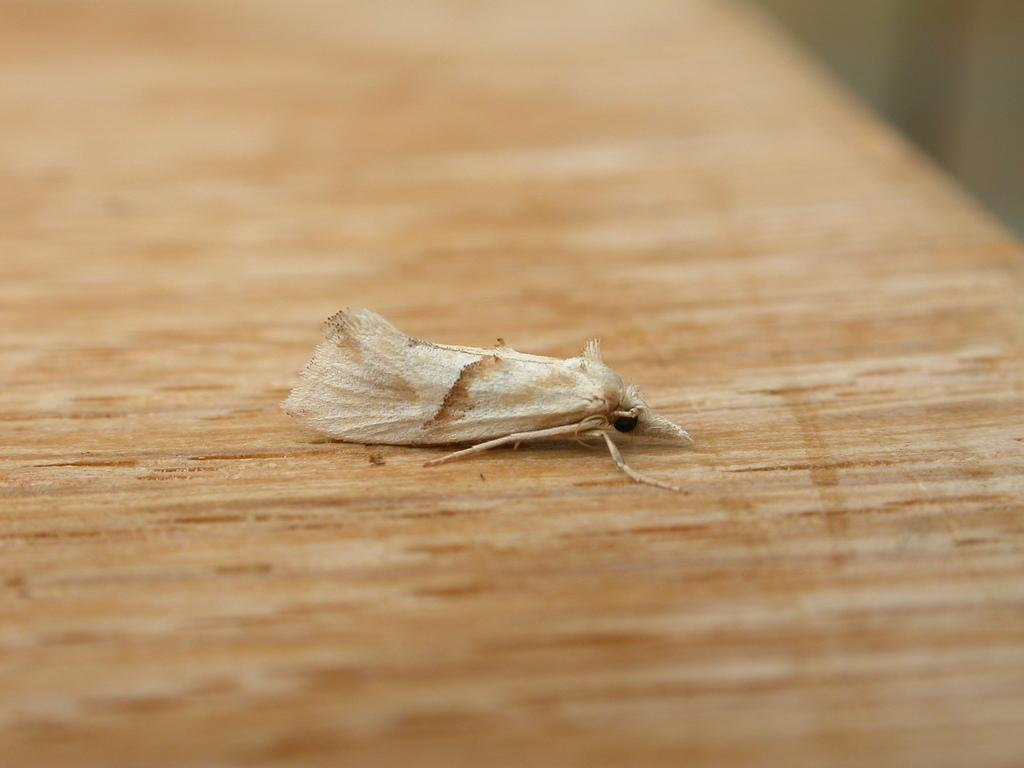What is the main subject in the center of the image? There is a fly in the center of the image. What type of surface is the fly on? The fly is on wood. What type of bird can be seen flying in the sky in the image? There is no bird or sky visible in the image; it only features a fly on wood. What type of currency exchange is happening in the image? There is no currency exchange happening in the image; it only features a fly on wood. 